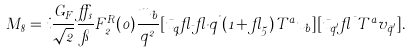<formula> <loc_0><loc_0><loc_500><loc_500>M _ { 8 } = i \frac { G _ { F } } { \sqrt { 2 } } \frac { \alpha _ { s } } { \pi } F ^ { R } _ { 2 } ( 0 ) \frac { m _ { b } } { q ^ { 2 } } [ \bar { u } _ { q } \gamma _ { \mu } \gamma _ { \nu } q ^ { \nu } ( 1 + \gamma _ { 5 } ) T ^ { a } u _ { b } ] [ \bar { u } _ { q ^ { \prime } } \gamma ^ { \mu } T ^ { a } v _ { \bar { q } ^ { \prime } } ] .</formula> 